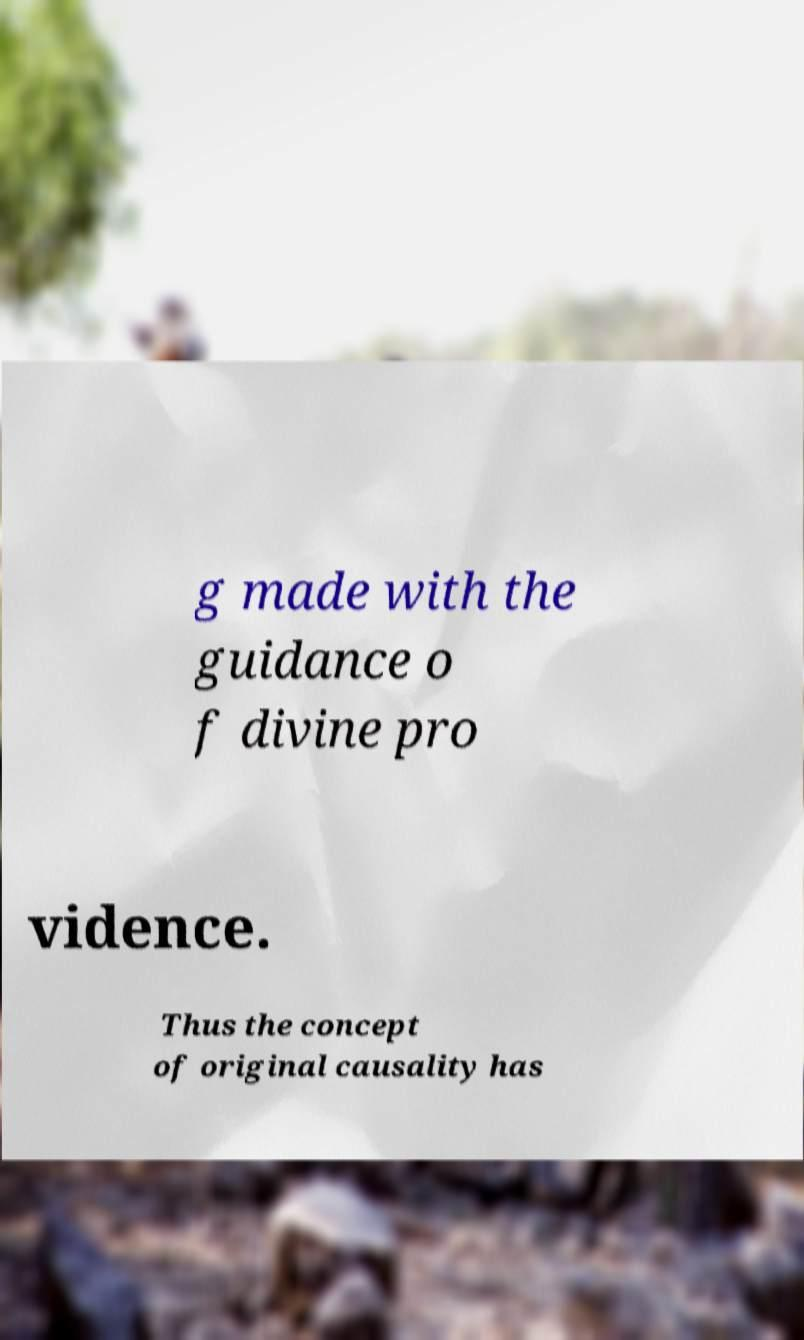Can you accurately transcribe the text from the provided image for me? g made with the guidance o f divine pro vidence. Thus the concept of original causality has 